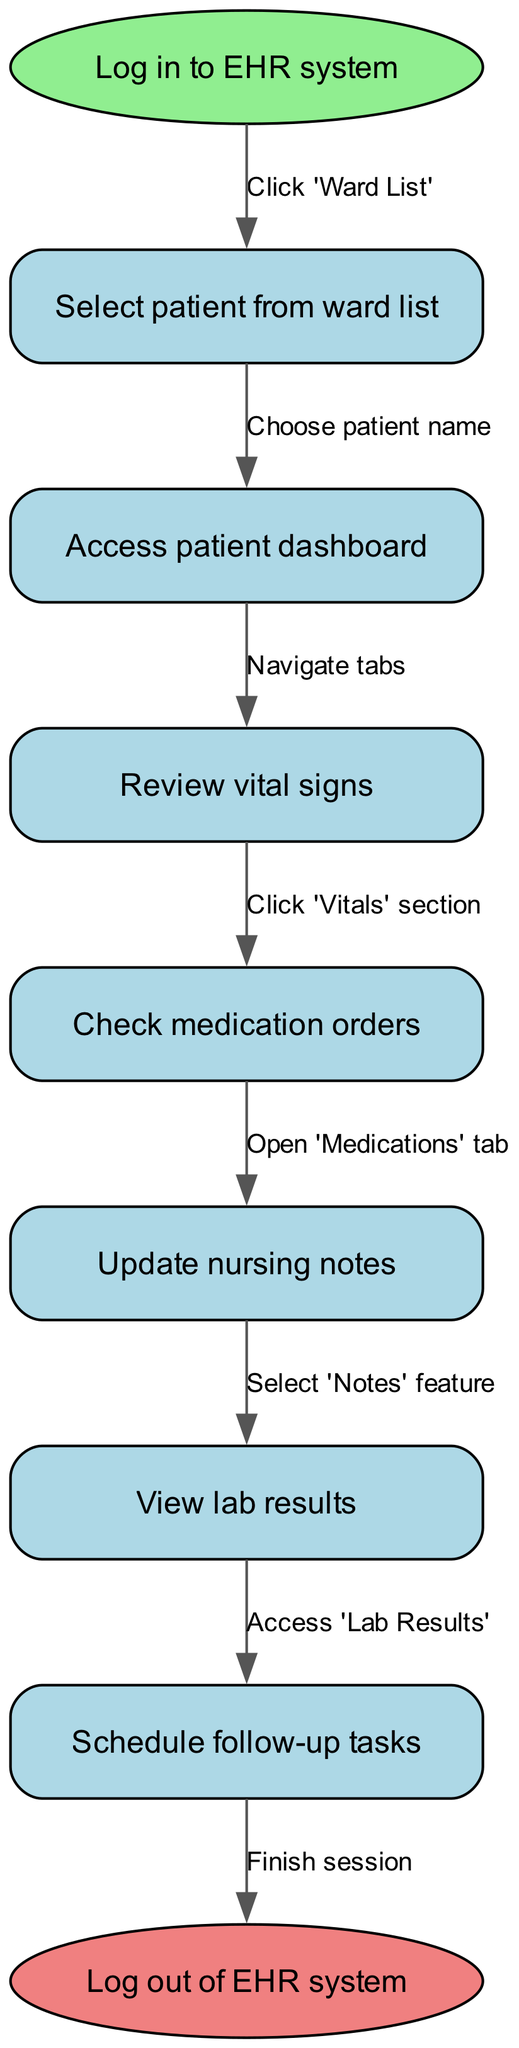What is the starting point of the EHR navigation? The diagram specifies that the starting point is to "Log in to EHR system." This is indicated by the labeled start node in the flowchart.
Answer: Log in to EHR system How many nodes are present in the diagram? By counting the listed actions within the "nodes" section of the data, there are a total of 7 nodes, including both the start and end nodes.
Answer: 8 What action comes after selecting a patient from the ward list? The transition from "Select patient from ward list" leads directly to "Access patient dashboard", as indicated by the arrow in the flowchart depicting the sequence.
Answer: Access patient dashboard What is the last action before logging out of the EHR system? The final step before the end node is "Schedule follow-up tasks." This is derived from following the sequence of nodes leading to the end point.
Answer: Schedule follow-up tasks Which section needs to be clicked to review vital signs? The edge going from "Access patient dashboard" to "Review vital signs" specifically indicates "Click 'Vitals' section" as the action needed to proceed.
Answer: Click 'Vitals' section Which task requires accessing 'Lab Results'? From "View lab results," the edge signifies a direct action leading to this node, affirming that this is the required task to view results.
Answer: Access 'Lab Results' How many edges are drawn from the start node? The starting node has one outgoing edge, as only one action initiates the sequence of steps to follow.
Answer: 1 What is the relationship between 'Check medication orders' and 'Update nursing notes'? The flowchart shows that 'Check medication orders' leads directly to 'Update nursing notes', establishing a sequential relationship between these two actions.
Answer: Sequential relationship 